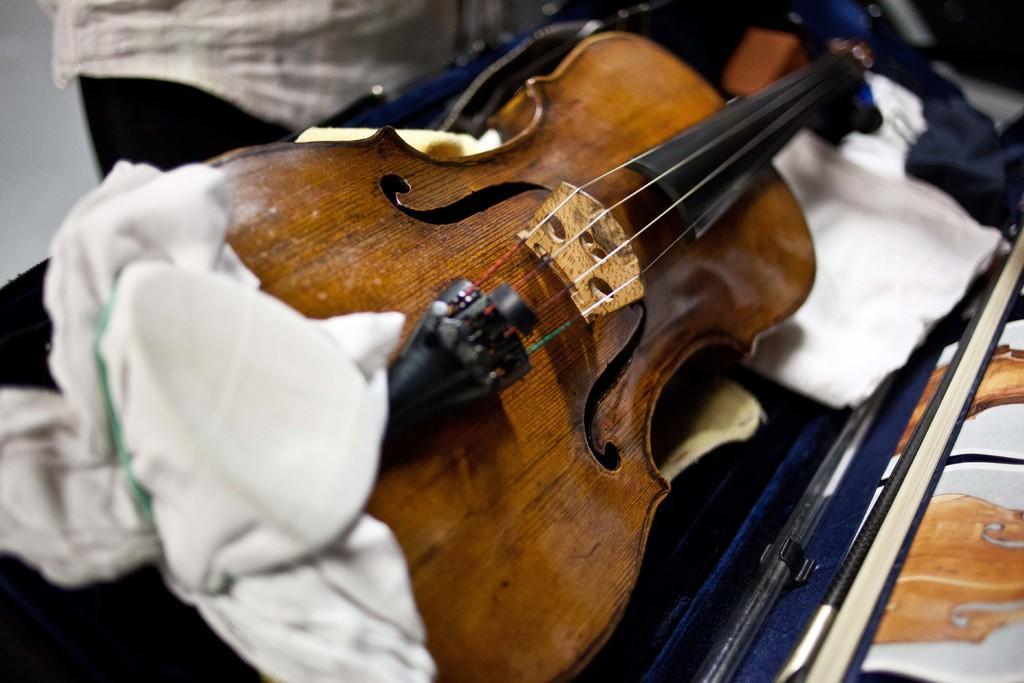In one or two sentences, can you explain what this image depicts? In this picture we can able to see a guitar on guitar bag. Beside this guitar a person is standing. 